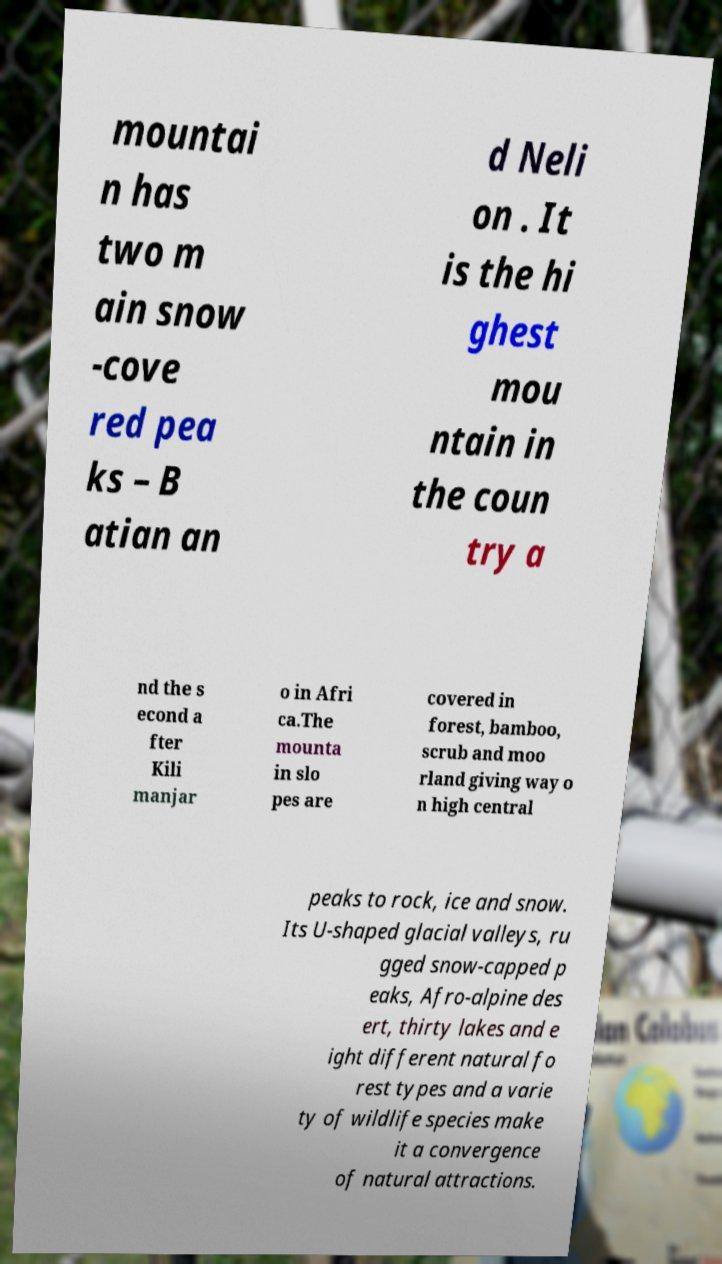There's text embedded in this image that I need extracted. Can you transcribe it verbatim? mountai n has two m ain snow -cove red pea ks – B atian an d Neli on . It is the hi ghest mou ntain in the coun try a nd the s econd a fter Kili manjar o in Afri ca.The mounta in slo pes are covered in forest, bamboo, scrub and moo rland giving way o n high central peaks to rock, ice and snow. Its U-shaped glacial valleys, ru gged snow-capped p eaks, Afro-alpine des ert, thirty lakes and e ight different natural fo rest types and a varie ty of wildlife species make it a convergence of natural attractions. 